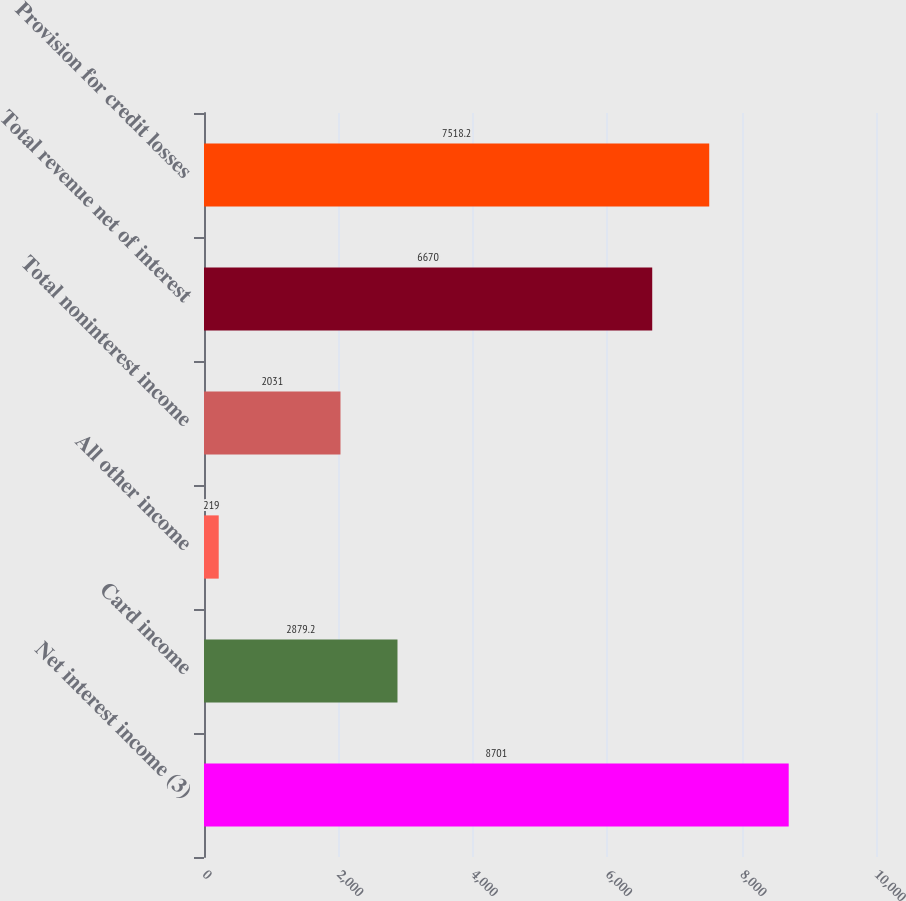Convert chart. <chart><loc_0><loc_0><loc_500><loc_500><bar_chart><fcel>Net interest income (3)<fcel>Card income<fcel>All other income<fcel>Total noninterest income<fcel>Total revenue net of interest<fcel>Provision for credit losses<nl><fcel>8701<fcel>2879.2<fcel>219<fcel>2031<fcel>6670<fcel>7518.2<nl></chart> 